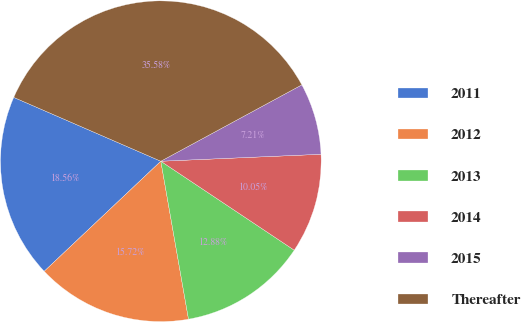<chart> <loc_0><loc_0><loc_500><loc_500><pie_chart><fcel>2011<fcel>2012<fcel>2013<fcel>2014<fcel>2015<fcel>Thereafter<nl><fcel>18.56%<fcel>15.72%<fcel>12.88%<fcel>10.05%<fcel>7.21%<fcel>35.58%<nl></chart> 